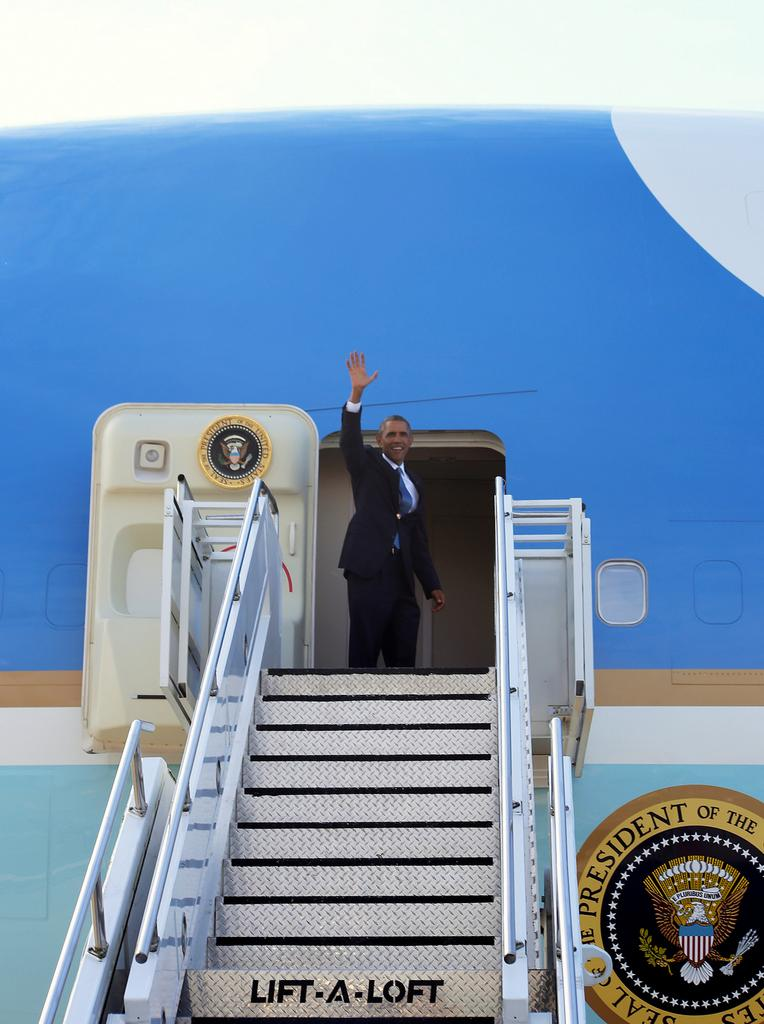What is the person in the image doing? The person is standing beside an airplane door. What can be seen in the image besides the person and the airplane door? There is a staircase in the image. What is on the airplane that can be seen in the image? There is a logo with some text on it. What is visible in the background of the image? The sky is visible in the background of the image. What type of book is the goat reading in the image? There is no goat or book present in the image. 